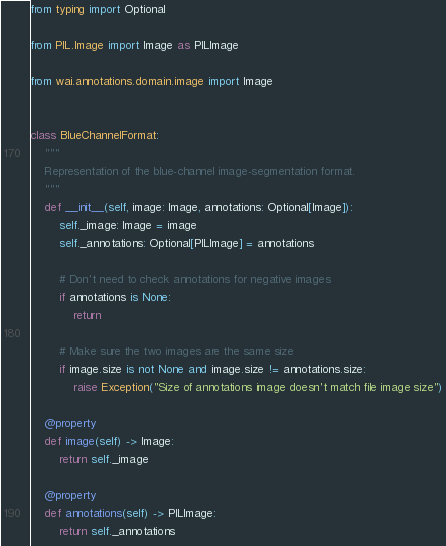<code> <loc_0><loc_0><loc_500><loc_500><_Python_>from typing import Optional

from PIL.Image import Image as PILImage

from wai.annotations.domain.image import Image


class BlueChannelFormat:
    """
    Representation of the blue-channel image-segmentation format.
    """
    def __init__(self, image: Image, annotations: Optional[Image]):
        self._image: Image = image
        self._annotations: Optional[PILImage] = annotations

        # Don't need to check annotations for negative images
        if annotations is None:
            return

        # Make sure the two images are the same size
        if image.size is not None and image.size != annotations.size:
            raise Exception("Size of annotations image doesn't match file image size")

    @property
    def image(self) -> Image:
        return self._image

    @property
    def annotations(self) -> PILImage:
        return self._annotations
</code> 